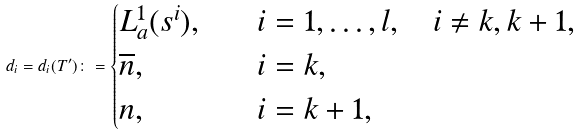Convert formula to latex. <formula><loc_0><loc_0><loc_500><loc_500>d _ { i } = d _ { i } ( T ^ { \prime } ) \colon = \begin{cases} L _ { a } ^ { 1 } ( s ^ { i } ) , & \quad i = 1 , \dots , l , \quad i \ne k , k + 1 , \\ \overline { n } , & \quad i = k , \\ n , & \quad i = k + 1 , \end{cases}</formula> 